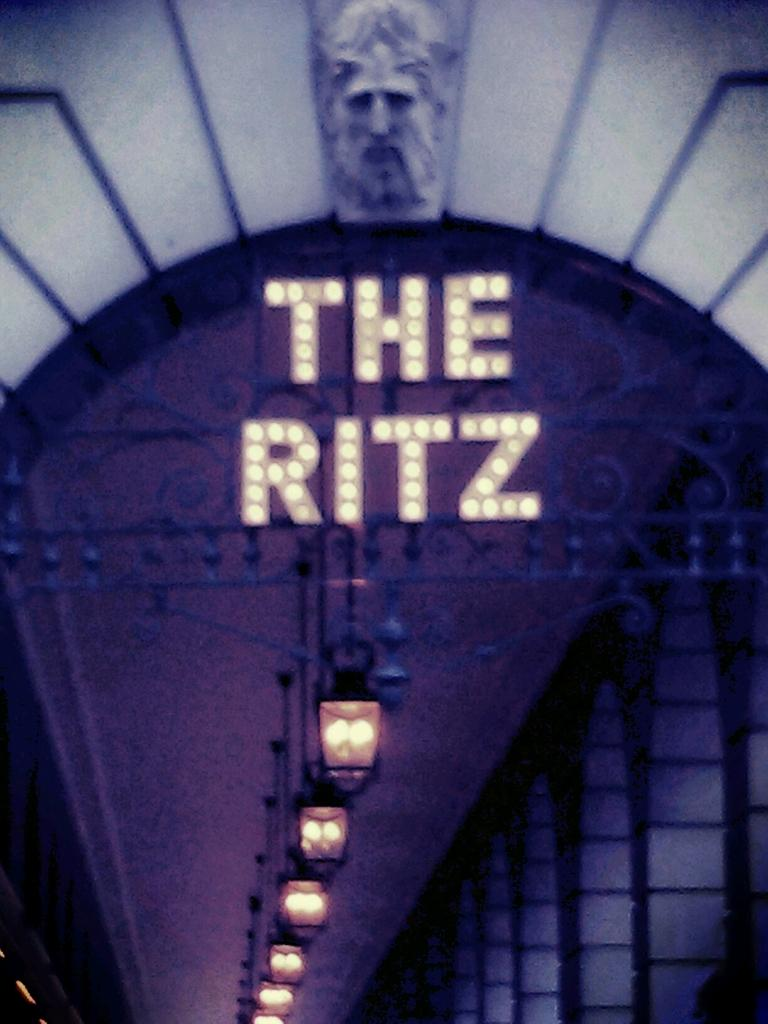What type of electronic device is present in the image? There is an LED light board in the image. Can you describe the person's face in the image? A person's face is visible in the image. What type of lighting is present in the room? There are ceiling lights in the image. How would you describe the overall lighting in the image? The background of the image is dark. What type of teeth can be seen on the icicle in the image? There is no icicle present in the image, and therefore no teeth can be observed on it. Can you tell me how many grandfathers are visible in the image? There is no mention of a grandfather or any family members in the image. 